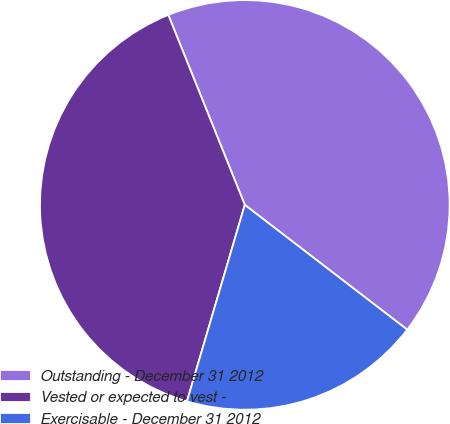Convert chart. <chart><loc_0><loc_0><loc_500><loc_500><pie_chart><fcel>Outstanding - December 31 2012<fcel>Vested or expected to vest -<fcel>Exercisable - December 31 2012<nl><fcel>41.52%<fcel>39.35%<fcel>19.13%<nl></chart> 